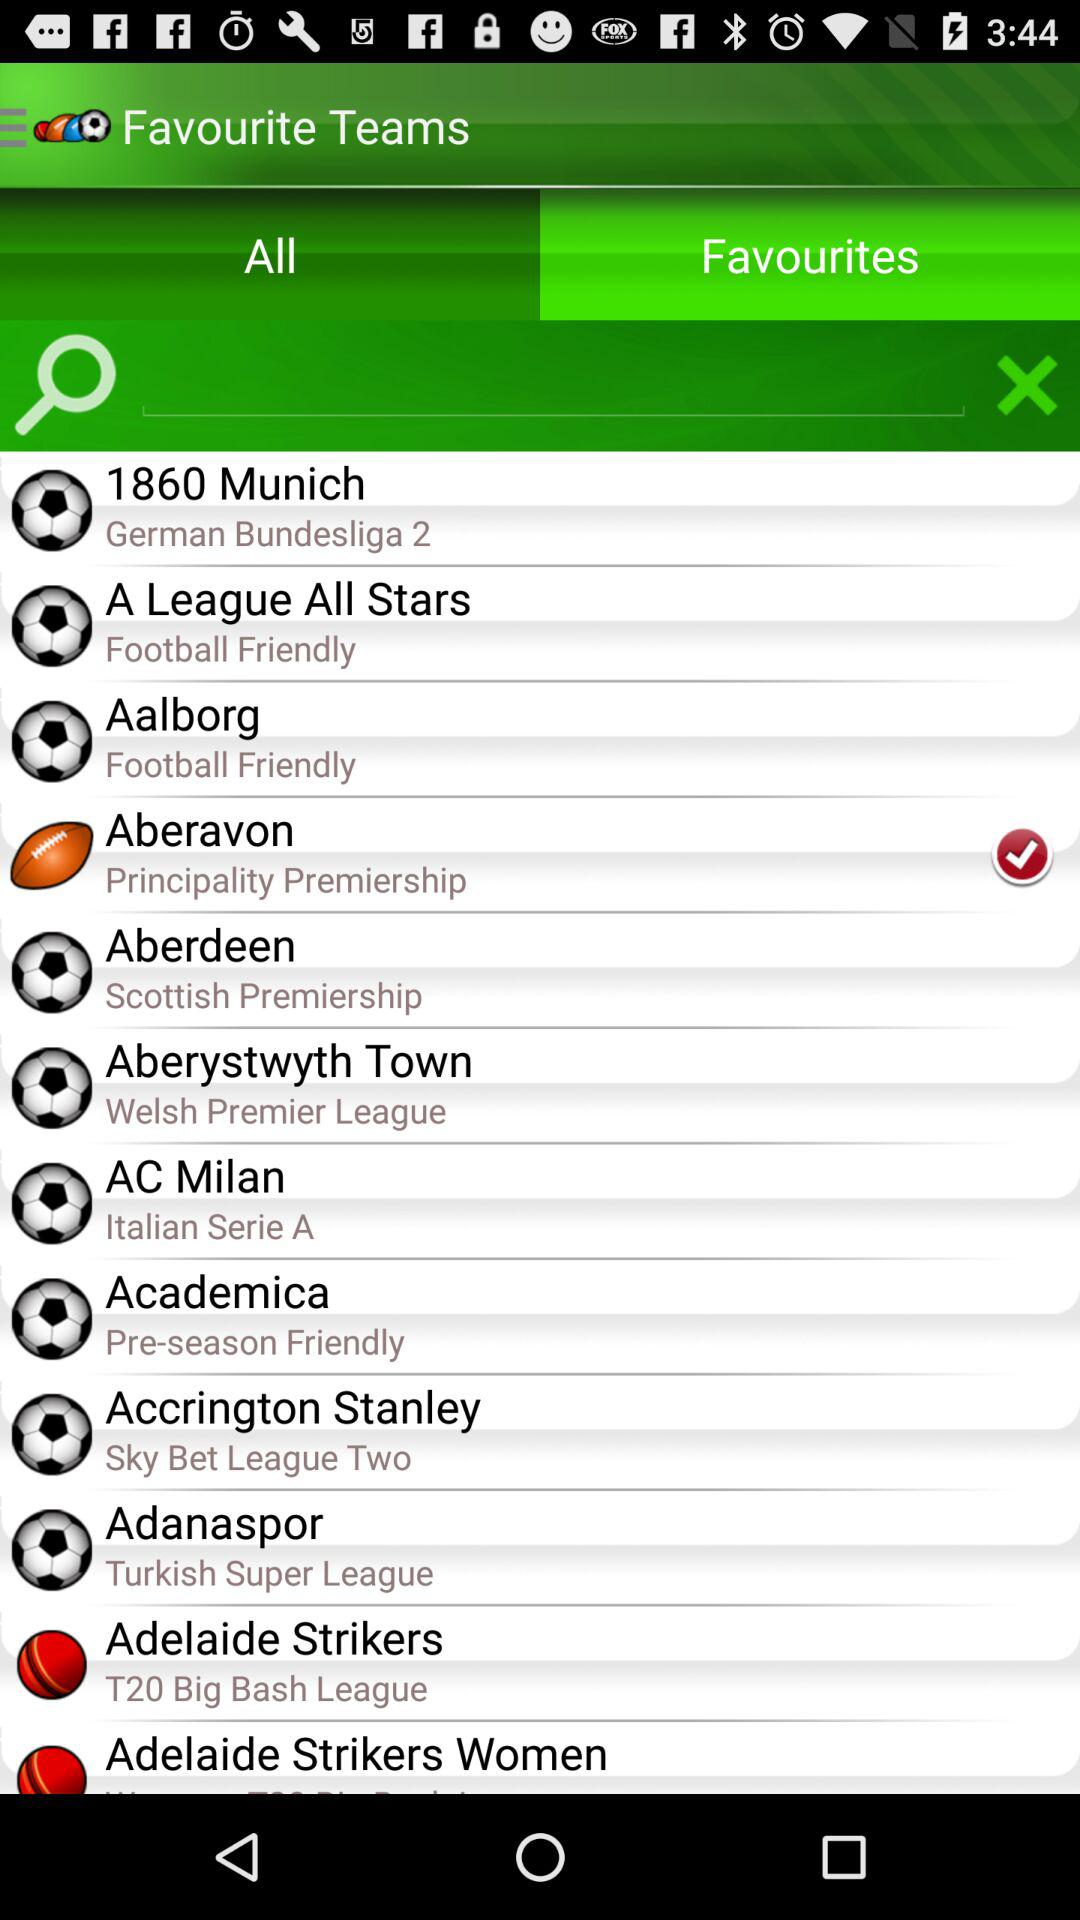Which team is selected? The selected team is Aberavon. 